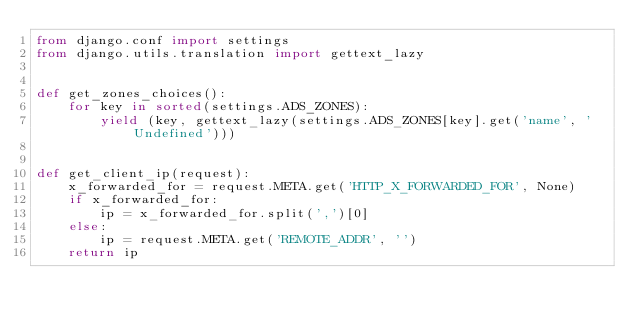Convert code to text. <code><loc_0><loc_0><loc_500><loc_500><_Python_>from django.conf import settings
from django.utils.translation import gettext_lazy


def get_zones_choices():
    for key in sorted(settings.ADS_ZONES):
        yield (key, gettext_lazy(settings.ADS_ZONES[key].get('name', 'Undefined')))


def get_client_ip(request):
    x_forwarded_for = request.META.get('HTTP_X_FORWARDED_FOR', None)
    if x_forwarded_for:
        ip = x_forwarded_for.split(',')[0]
    else:
        ip = request.META.get('REMOTE_ADDR', '')
    return ip
</code> 